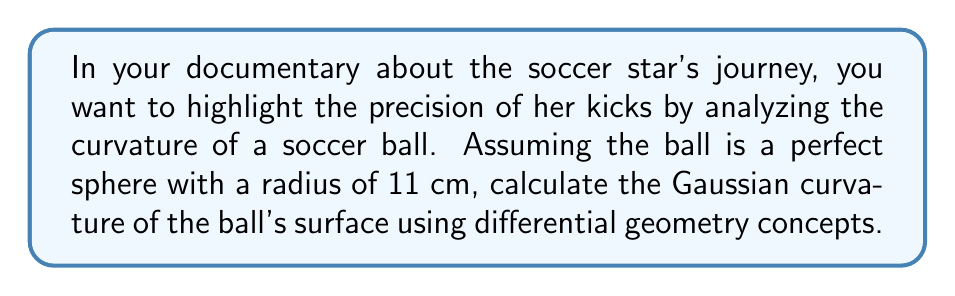Teach me how to tackle this problem. Let's approach this step-by-step:

1) In differential geometry, the Gaussian curvature (K) of a sphere is constant over its entire surface and is given by the formula:

   $$K = \frac{1}{R^2}$$

   where R is the radius of the sphere.

2) We are given that the radius of the soccer ball is 11 cm. Let's substitute this into our formula:

   $$K = \frac{1}{(11 \text{ cm})^2}$$

3) Simplify:
   
   $$K = \frac{1}{121 \text{ cm}^2}$$

4) To express this in standard units, we should convert cm^2 to m^2:
   
   $$K = \frac{1}{121 \times 10^{-4} \text{ m}^2} = \frac{10^4}{121} \text{ m}^{-2}$$

5) Simplifying further:

   $$K \approx 82.6446 \text{ m}^{-2}$$

This constant positive Gaussian curvature indicates that the soccer ball's surface is uniformly curved outward at every point, which is characteristic of a perfect sphere.
Answer: $K \approx 82.6446 \text{ m}^{-2}$ 